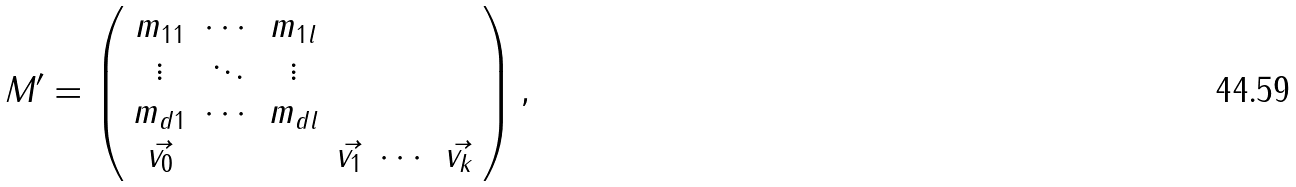<formula> <loc_0><loc_0><loc_500><loc_500>M ^ { \prime } = \left ( \begin{array} { c c c c c c } m _ { 1 1 } & \cdots & m _ { 1 l } & & & \\ \vdots & \ddots & \vdots & & & \\ m _ { d 1 } & \cdots & m _ { d l } & & & \\ \vec { v _ { 0 } } & & & \vec { v _ { 1 } } & \cdots & \vec { v _ { k } } \end{array} \right ) ,</formula> 